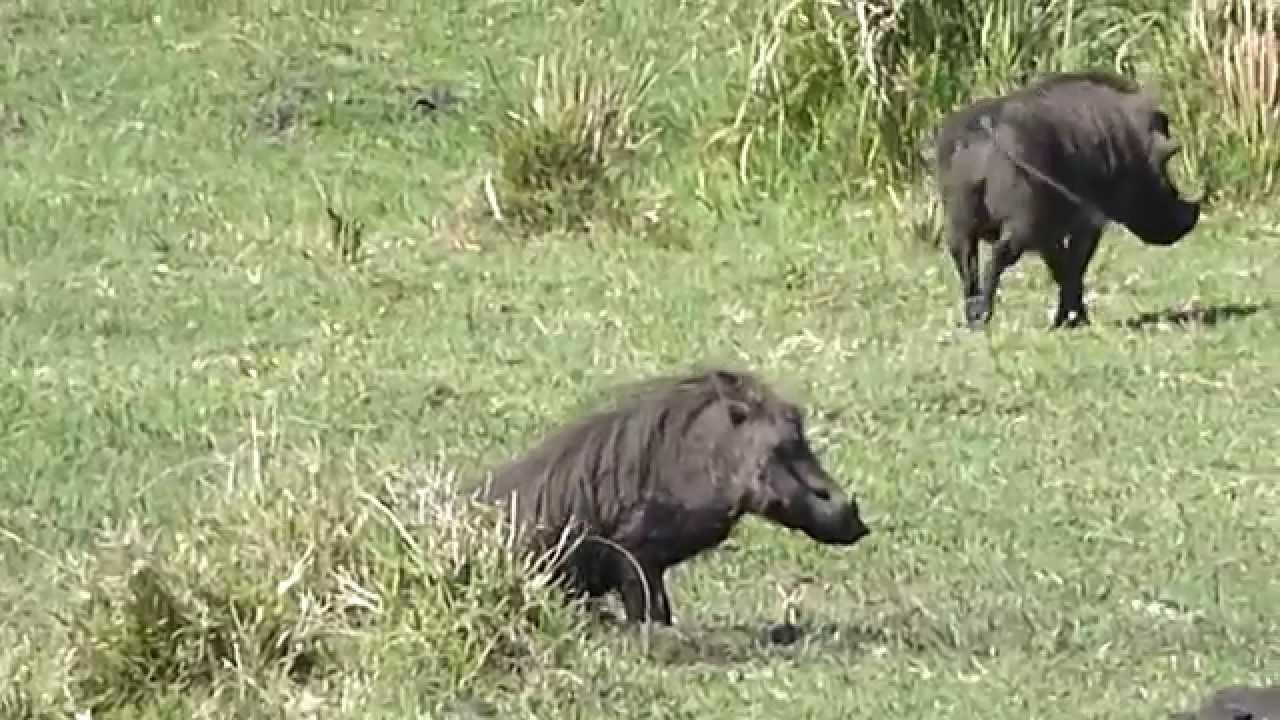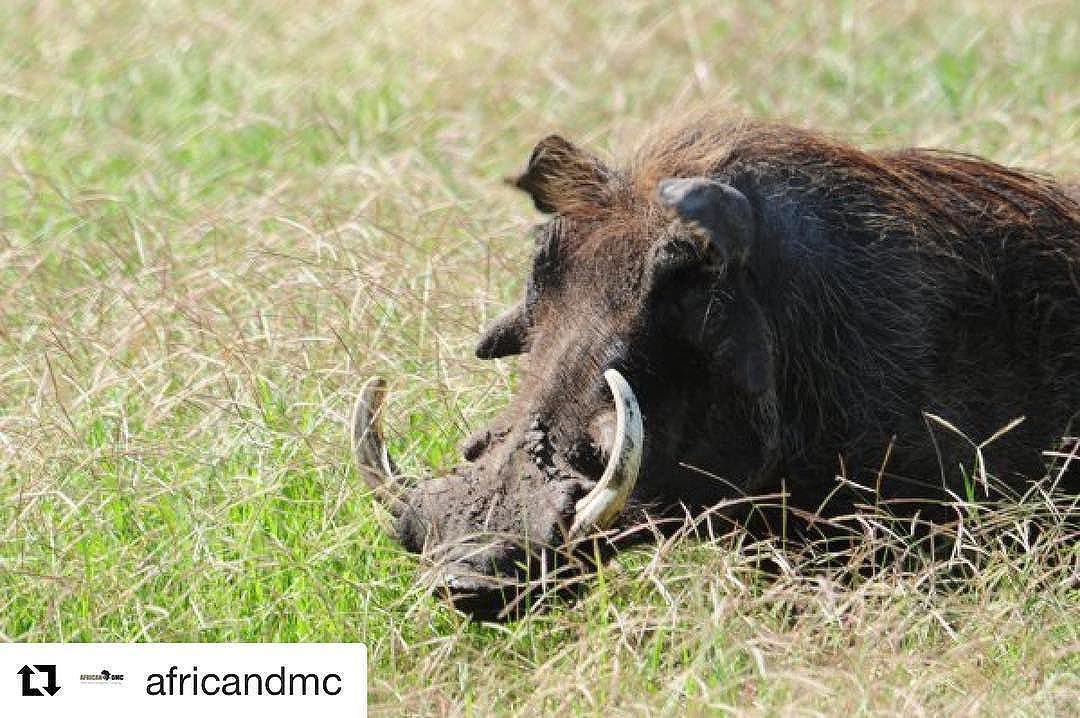The first image is the image on the left, the second image is the image on the right. Examine the images to the left and right. Is the description "One image shows a single warthog while the other shows no less than two warthogs." accurate? Answer yes or no. Yes. The first image is the image on the left, the second image is the image on the right. Considering the images on both sides, is "There are 3 warthogs in the image pair" valid? Answer yes or no. Yes. 